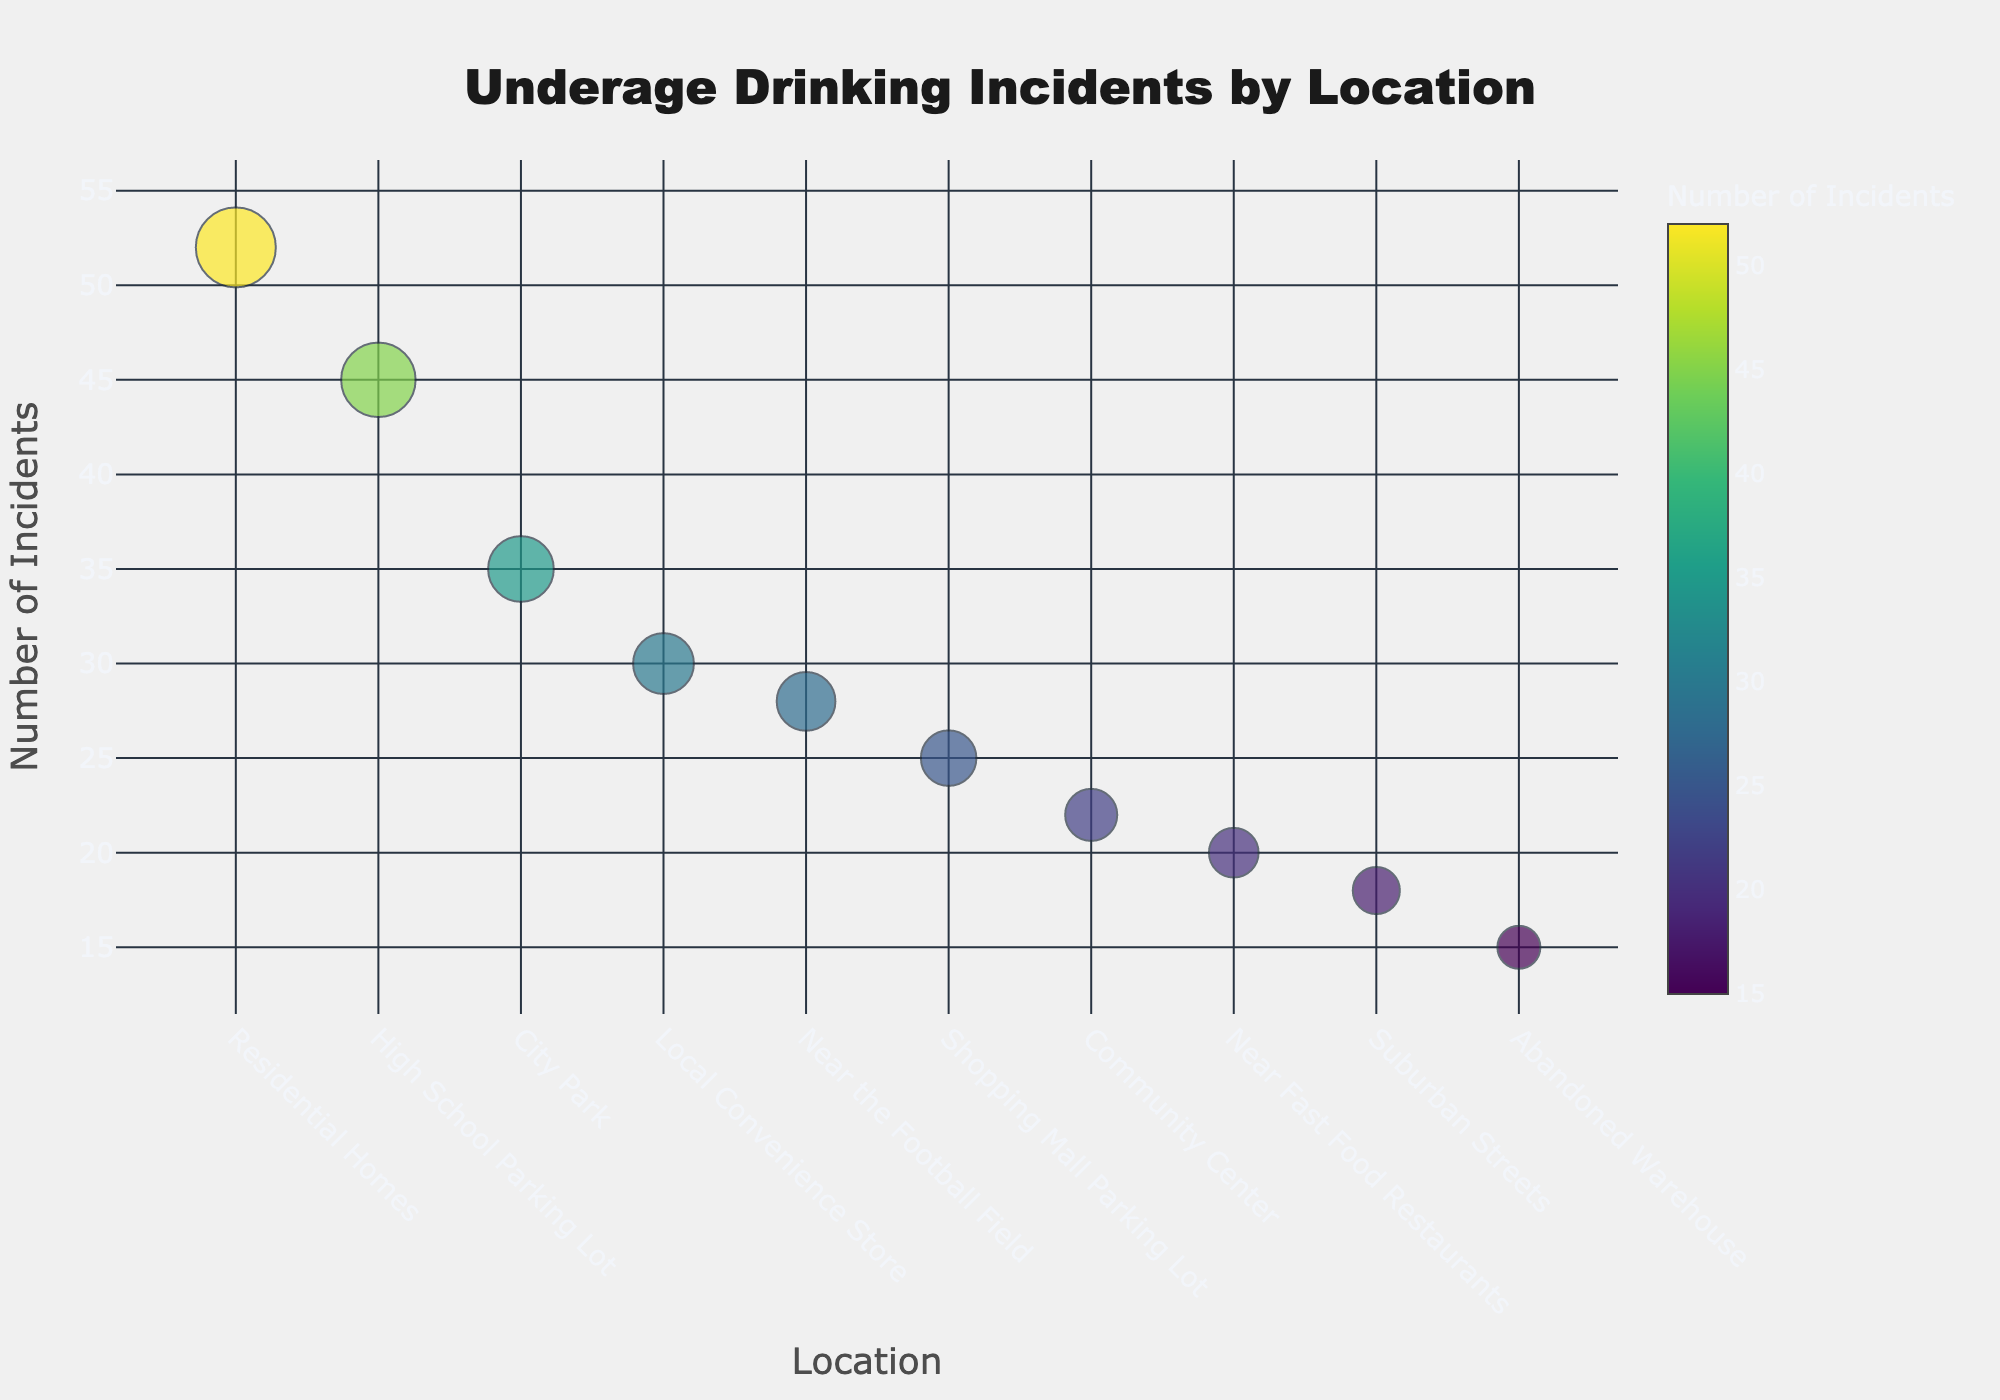What is the title of the bubble chart? The title is prominently displayed at the top of the figure. It reads "Underage Drinking Incidents by Location".
Answer: Underage Drinking Incidents by Location How many different locations are depicted in the bubble chart? The chart includes individual bubbles for each unique location listed. By counting these bubbles or referring to the distance names on the x-axis, we can see there are 10 locations shown.
Answer: 10 Which location has the highest number of underage drinking incidents? The y-axis of the bubble chart depicts the number of incidents, and the bubble with the highest position on this axis represents the location with the highest number of incidents. "Residential Homes" is the topmost bubble with 52 incidents.
Answer: Residential Homes Compare the number of incidents at the "City Park" and the "Abandoned Warehouse". Which one has more incidents? By comparing the positions of the bubbles labeled "City Park" and "Abandoned Warehouse" along the y-axis, we can see that "City Park" has 35 incidents, while "Abandoned Warehouse" has 15.
Answer: City Park What is the difference in the number of incidents between the Community Center and Near Fast Food Restaurants? The bubble representing the Community Center has 22 incidents, while the one for Near Fast Food Restaurants has 20. The difference is calculated as 22 - 20 = 2.
Answer: 2 What's the sum of incidents reported in "Shopping Mall Parking Lot" and "Local Convenience Store"? The number of incidents at the Shopping Mall Parking Lot is 25, and at the Local Convenience Store, it is 30. Summing these, we get 25 + 30 = 55.
Answer: 55 Which location has fewer incidents: Suburban Streets or Near the Football Field? By comparing the bubbles of "Suburban Streets" and "Near the Football Field" on the y-axis, we see that Suburban Streets have 18 incidents while Near the Football Field has 28 incidents.
Answer: Suburban Streets What's the average number of incidents for High School Parking Lot, Near the Football Field, and City Park? First, sum the incidents for these three locations: 45 (High School Parking Lot) + 28 (Near the Football Field) + 35 (City Park) = 108. Then divide by 3 to get the average: 108 / 3 = 36.
Answer: 36 What is the color scale used to represent the number of incidents in the bubble chart? Observing the color bar next to the figure, the chart employs the Viridis colorscale, where colors transition from blue to yellow according to the number of incidents.
Answer: Viridis 